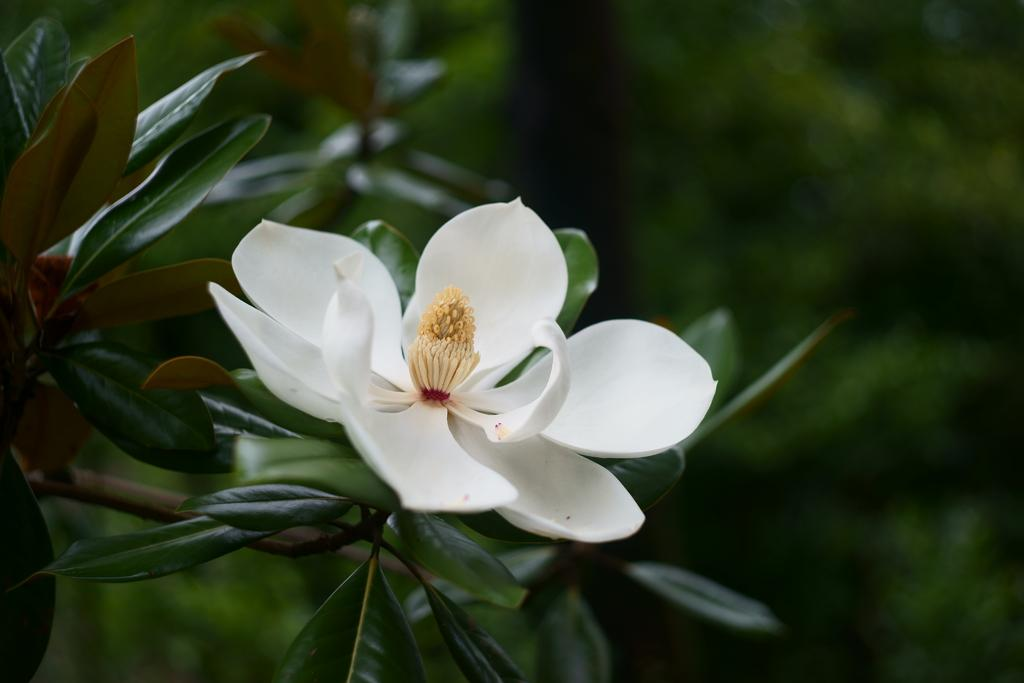What type of flower is in the image? There is a white flower in the image. What part of the flower is visible in the image? The flower has a stigma. What is present around the stigma? There are pollen grains around the stigma. What can be seen in the background of the image? There are green leaves in the background of the image. What type of plane can be seen flying over the flower in the image? There is no plane visible in the image; it only features a white flower with a stigma and pollen grains, as well as green leaves in the background. 